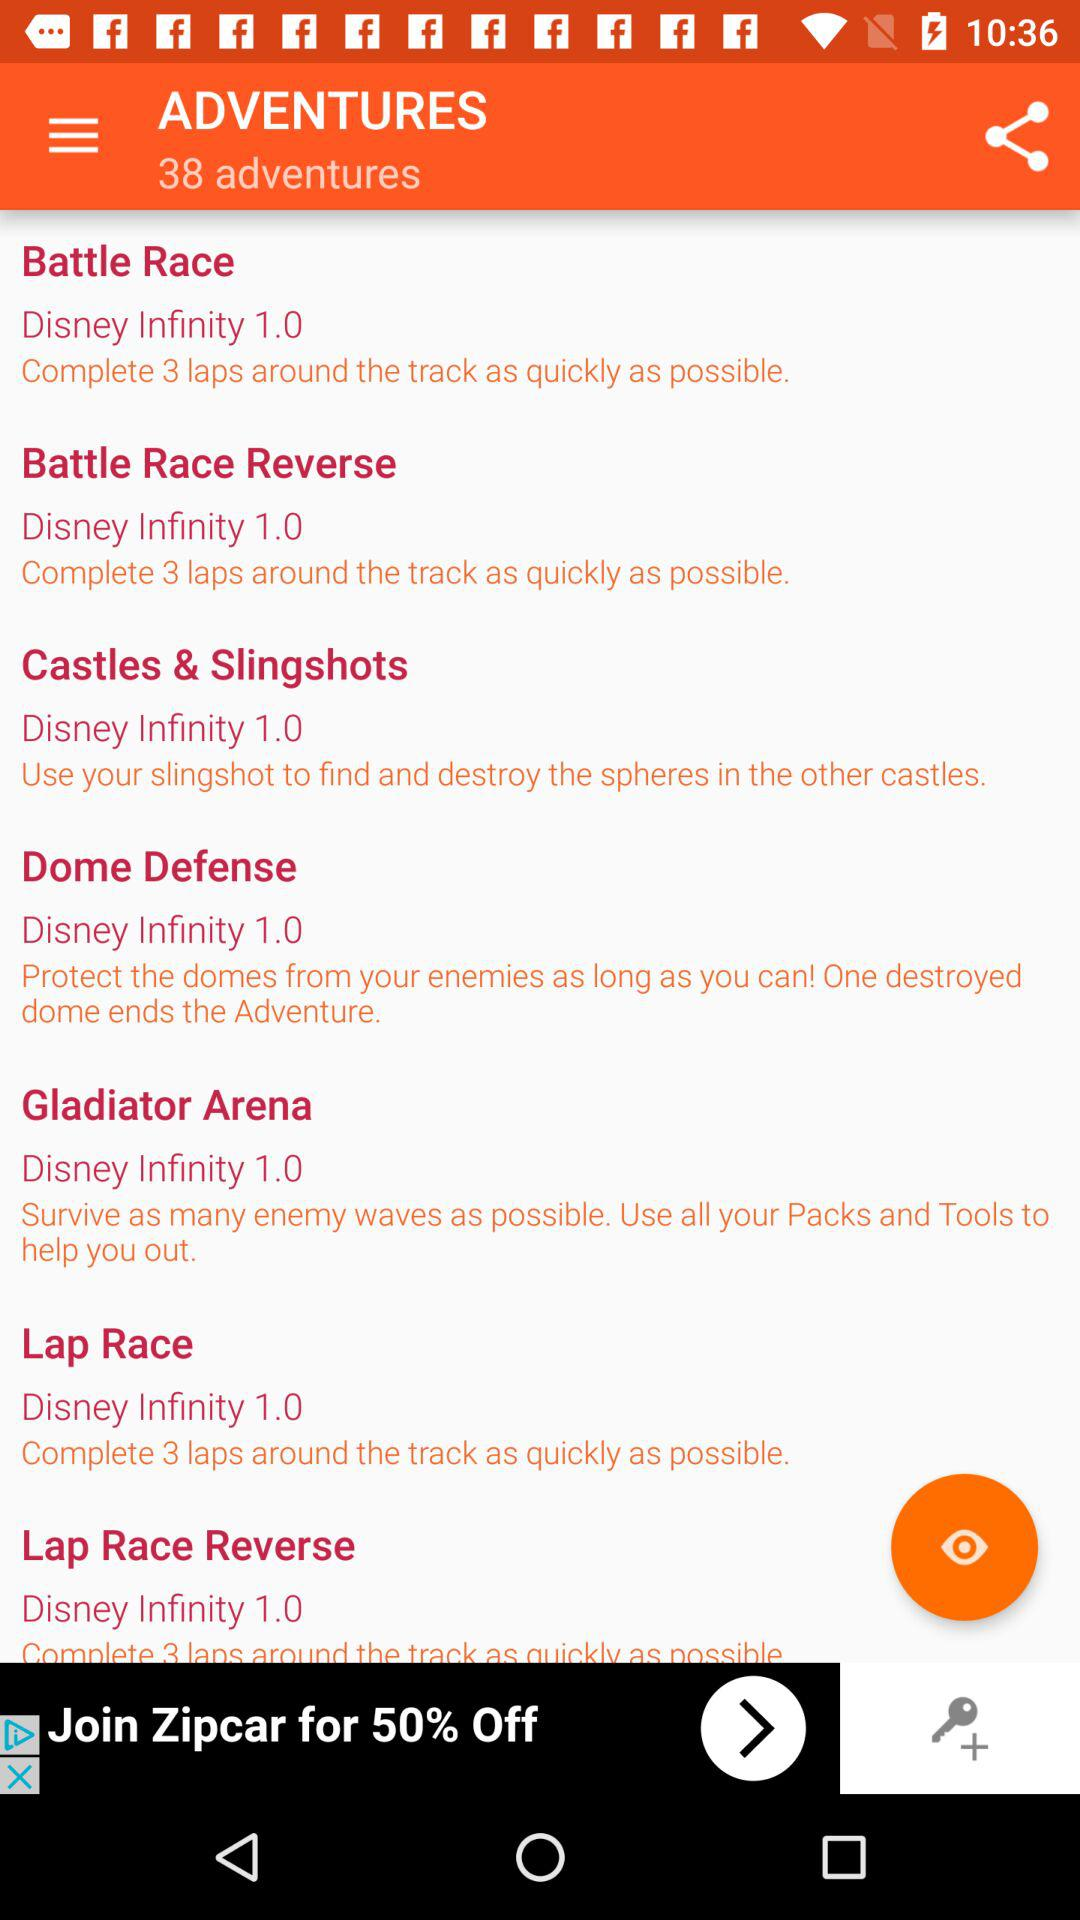How many adventures are there? There are 38 adventures. 